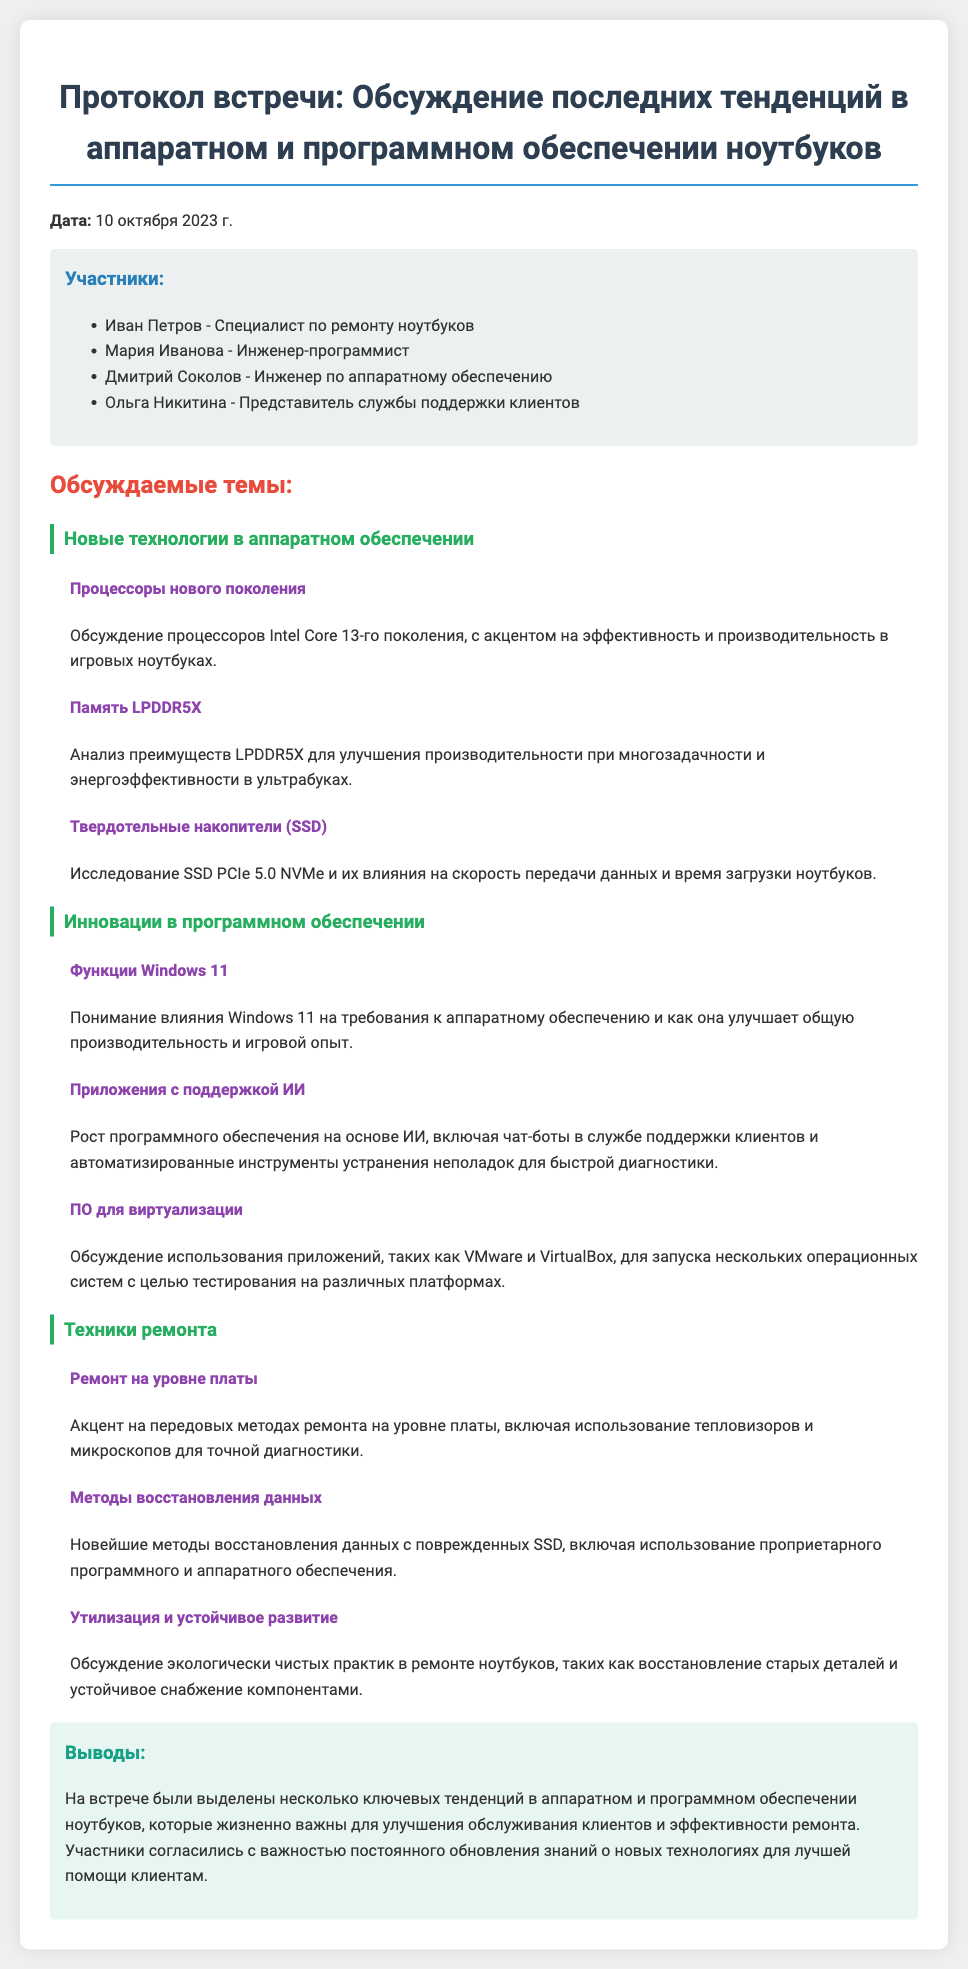Какая дата встречи? Дата встречи указана в документе как 10 октября 2023 г.
Answer: 10 октября 2023 г Кто является инженером-программистом на встрече? В списке участников указано имя инженера-программиста, Мария Иванова.
Answer: Мария Иванова Какой процессор обсуждается в тематике новых технологий? В разделе о новых технологиях упоминается процессоры Intel Core 13-го поколения.
Answer: Intel Core 13-го поколения Какое новое программное обеспечение было обсуждено на встрече? В разделе инновации в программном обеспечении упоминается Windows 11 как важное обновление.
Answer: Windows 11 Какая техника ремонта акцентируется на встрече? В разделе техник ремонта акцентируется на ремонте на уровне платы.
Answer: Ремонт на уровне платы Каковы преимущества LPDDR5X? Преимущества LPDDR5X касаются улучшения производительности при многозадачности и энергоэффективности.
Answer: Улучшение производительности при многозадачности и энергоэффективности Какова основная цель использования программного обеспечения на основе ИИ? Основная цель программного обеспечения на основе ИИ — это автоматизация диагностики и поддержка клиентов.
Answer: Автоматизация диагностики и поддержка клиентов Какие методы восстановления данных были обсуждены? Обсуждались новейшие методы восстановления данных с поврежденных SSD.
Answer: Новейшие методы восстановления данных с поврежденных SSD 